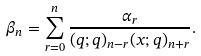<formula> <loc_0><loc_0><loc_500><loc_500>\beta _ { n } = \sum _ { r = 0 } ^ { n } \frac { \alpha _ { r } } { ( q ; q ) _ { n - r } ( x ; q ) _ { n + r } } .</formula> 